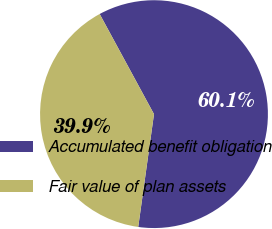Convert chart to OTSL. <chart><loc_0><loc_0><loc_500><loc_500><pie_chart><fcel>Accumulated benefit obligation<fcel>Fair value of plan assets<nl><fcel>60.12%<fcel>39.88%<nl></chart> 